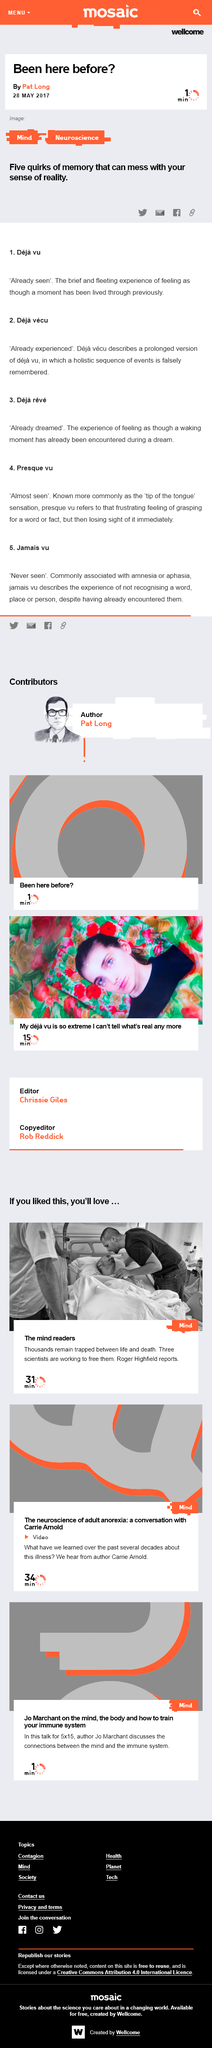List a handful of essential elements in this visual. Deja vu is the temporary feeling that one has experienced a moment before, even though it is clear that this is not the case. Deja reve is the experience of feeling as though a waking moment has already been encountered in a dream, which is a phenomenon characterized by a sense of familiarity and déjà vu. The five quirks of memory, including Deja vu, Deja vecu, Deja reve, Presque vu, and Jamais vu, can potentially alter one's sense of reality. 